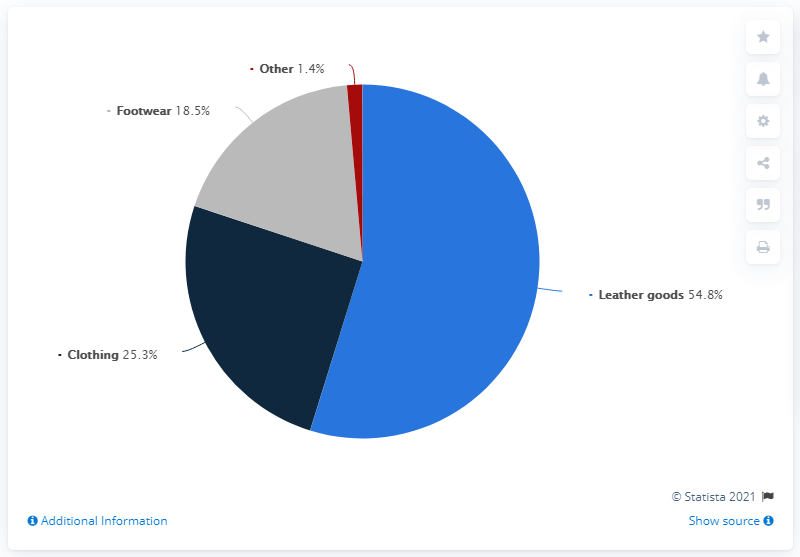Point out several critical features in this image. The total amount of clothing and other expenses is expected to be 26.7. The pie chart shows that footwear accounts for approximately 18.5% of the total market share. In 2020, Prada's footwear product line accounted for approximately 18.5% of the company's total net sales. 